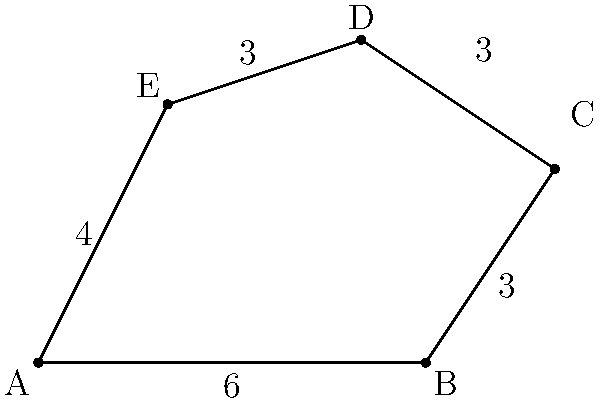In a high-stakes property negotiation, you're advising a client on the purchase of an irregularly shaped lot. The lot is represented by the polygon ABCDE in the diagram. Given that the measurements are in units of 100 feet, calculate the area of the lot in square feet. How would you present this information to strengthen your client's negotiating position? To calculate the area of this irregular polygon, we can use the following steps:

1. Divide the polygon into triangles: ABC, ACD, and ADE.

2. Calculate the area of each triangle using the formula: $A = \frac{1}{2} \times base \times height$

3. For triangle ABC:
   Base = 6 units (600 feet), Height = 3 units (300 feet)
   Area of ABC = $\frac{1}{2} \times 6 \times 3 = 9$ square units

4. For triangle ACD:
   We can calculate this by subtracting the area of triangle ABD from the area of trapezoid ABCD.
   Area of trapezoid ABCD = $\frac{1}{2}(6+5) \times 5 = 27.5$ square units
   Area of triangle ABD = $\frac{1}{2} \times 6 \times 5 = 15$ square units
   Area of ACD = $27.5 - 15 = 12.5$ square units

5. For triangle ADE:
   Base = 4 units (400 feet), Height = 4 units (400 feet)
   Area of ADE = $\frac{1}{2} \times 4 \times 4 = 8$ square units

6. Total area = Area of ABC + Area of ACD + Area of ADE
               = $9 + 12.5 + 8 = 29.5$ square units

7. Convert to square feet: $29.5 \times (100 \text{ ft})^2 = 295,000$ square feet

To strengthen the negotiating position, you could present this precise calculation to ensure a fair price per square foot, compare it to similar properties in the area, or use it to discuss potential development opportunities based on the lot's size.
Answer: 295,000 square feet 